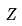<formula> <loc_0><loc_0><loc_500><loc_500>Z</formula> 